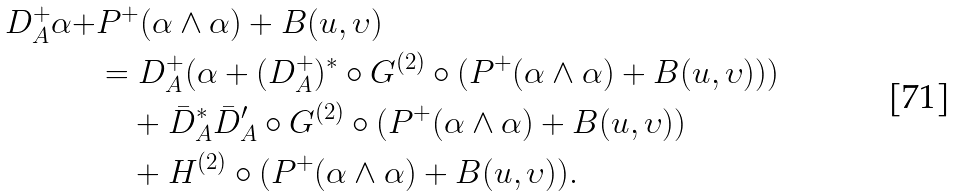Convert formula to latex. <formula><loc_0><loc_0><loc_500><loc_500>D _ { A } ^ { + } \alpha + & P ^ { + } ( \alpha \wedge \alpha ) + B ( u , \upsilon ) \\ & = D _ { A } ^ { + } ( \alpha + ( D _ { A } ^ { + } ) ^ { * } \circ G ^ { ( 2 ) } \circ ( P ^ { + } ( \alpha \wedge \alpha ) + B ( u , \upsilon ) ) ) \\ & \quad + \bar { D } _ { A } ^ { * } \bar { D } _ { A } ^ { \prime } \circ G ^ { ( 2 ) } \circ ( P ^ { + } ( \alpha \wedge \alpha ) + B ( u , \upsilon ) ) \\ & \quad + H ^ { ( 2 ) } \circ ( P ^ { + } ( \alpha \wedge \alpha ) + B ( u , \upsilon ) ) .</formula> 